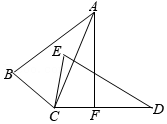Can you discuss the significance of perpendicular line AF in relation to triangle DEC and its angles? The perpendicular line AF is vital as it establishes specific geometric conditions within triangle DEC. By intersecting line CD at point F, AF creates two right angles, angle AFD and angle AFC, each measuring 90°. This perpendicular intersection significantly influences the calculations involving the angles of the triangles, especially concerning the angles at point F. For instance, known measures of angles such as DCE or BCE (if provided) can be utilized in conjunction with the perpendicular nature of AF to calculate other angles like CAF by subtracting from 90°. This setup is very useful in trigonometric calculations and proving certain properties within the triangle. 